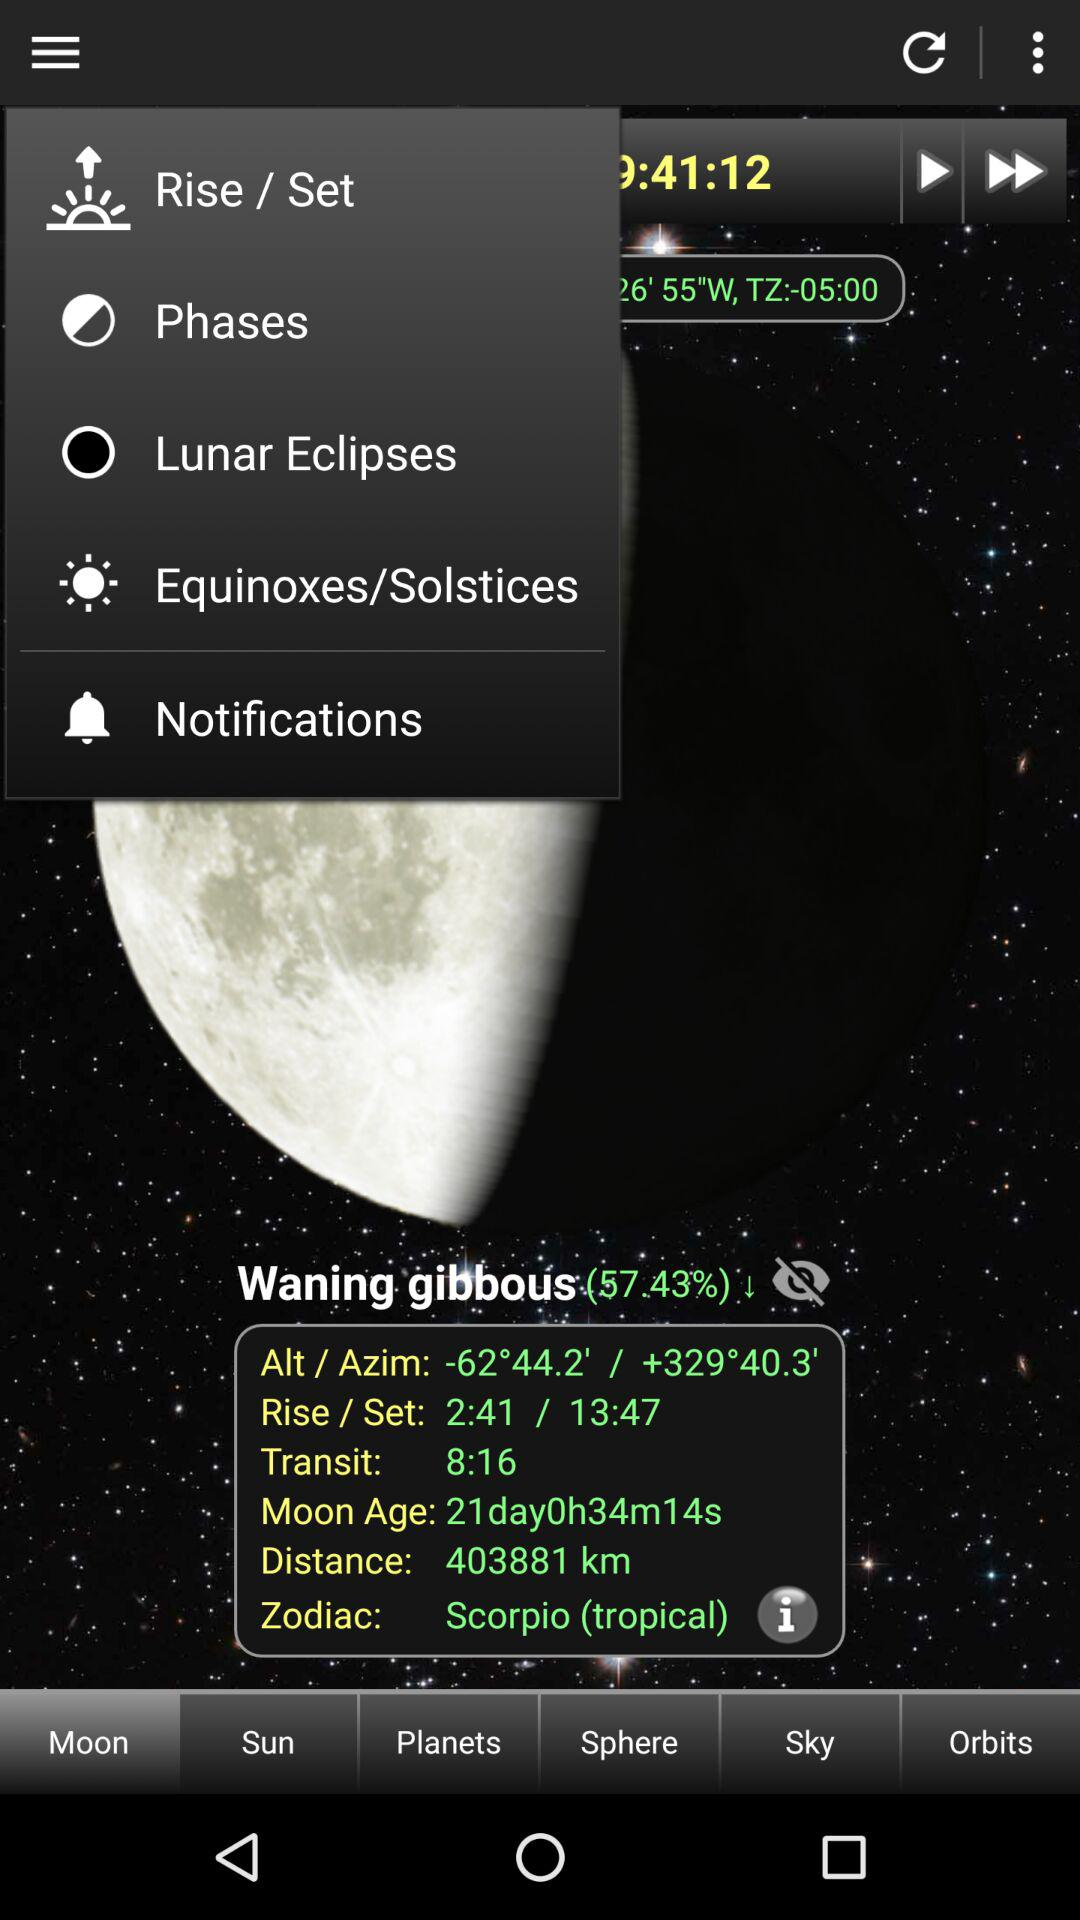What is the transit time? The transit time is 8:16. 